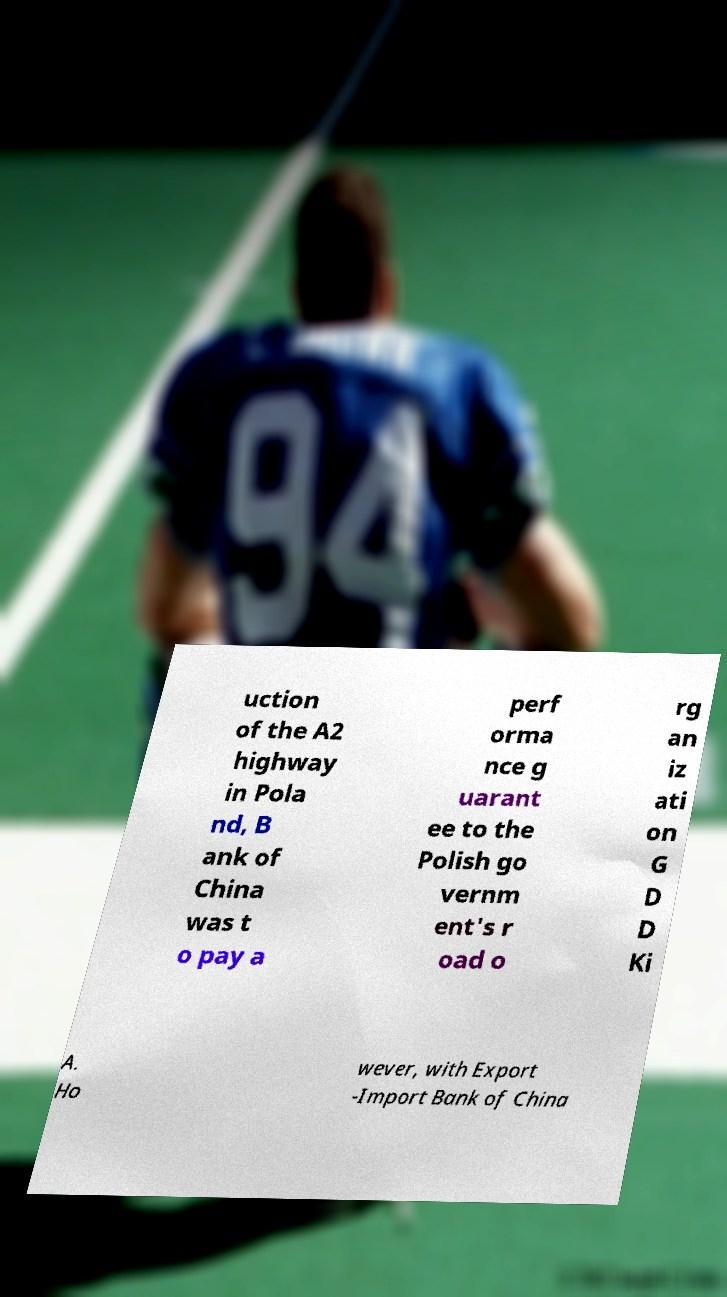Can you accurately transcribe the text from the provided image for me? uction of the A2 highway in Pola nd, B ank of China was t o pay a perf orma nce g uarant ee to the Polish go vernm ent's r oad o rg an iz ati on G D D Ki A. Ho wever, with Export -Import Bank of China 